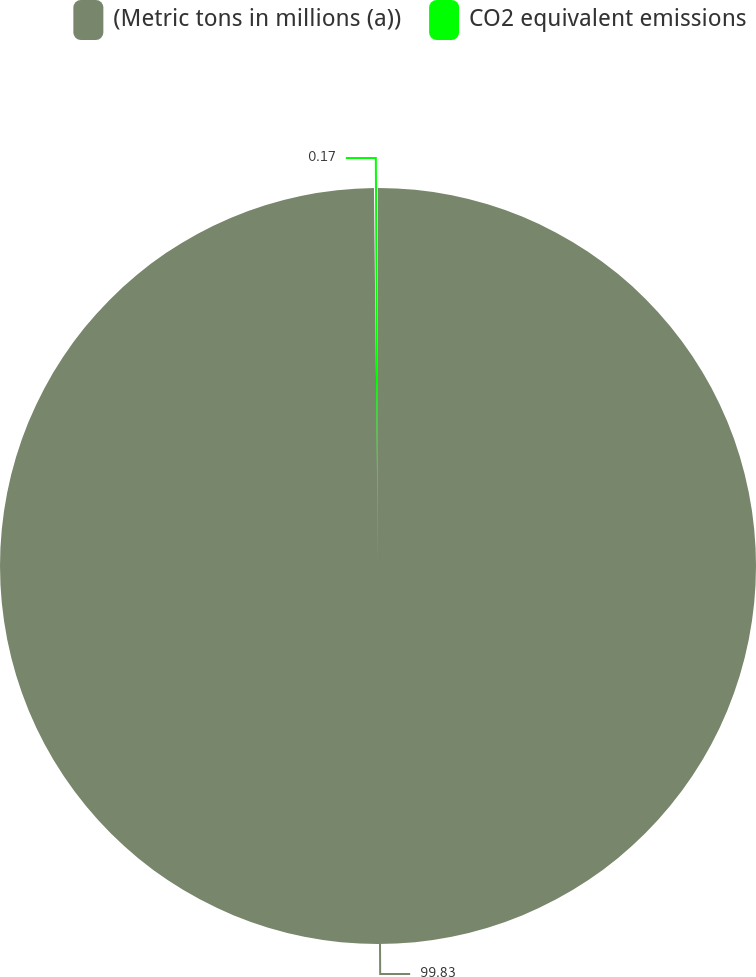Convert chart. <chart><loc_0><loc_0><loc_500><loc_500><pie_chart><fcel>(Metric tons in millions (a))<fcel>CO2 equivalent emissions<nl><fcel>99.83%<fcel>0.17%<nl></chart> 